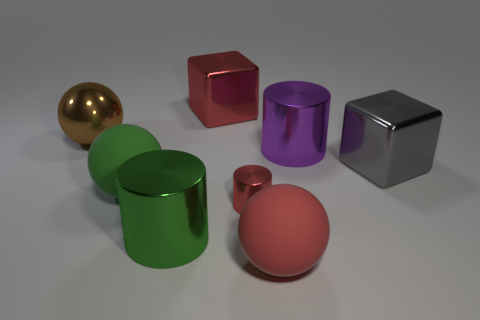Add 1 cylinders. How many objects exist? 9 Subtract all cylinders. How many objects are left? 5 Add 1 yellow cylinders. How many yellow cylinders exist? 1 Subtract 1 gray blocks. How many objects are left? 7 Subtract all green cylinders. Subtract all large purple cylinders. How many objects are left? 6 Add 8 purple cylinders. How many purple cylinders are left? 9 